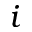<formula> <loc_0><loc_0><loc_500><loc_500>i</formula> 